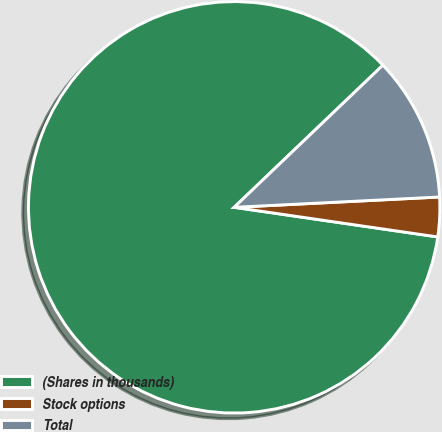Convert chart to OTSL. <chart><loc_0><loc_0><loc_500><loc_500><pie_chart><fcel>(Shares in thousands)<fcel>Stock options<fcel>Total<nl><fcel>85.56%<fcel>3.1%<fcel>11.34%<nl></chart> 